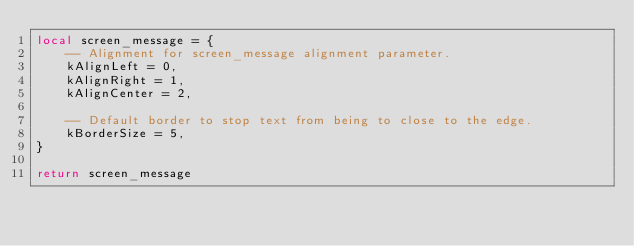Convert code to text. <code><loc_0><loc_0><loc_500><loc_500><_Lua_>local screen_message = {
    -- Alignment for screen_message alignment parameter.
    kAlignLeft = 0,
    kAlignRight = 1,
    kAlignCenter = 2,

    -- Default border to stop text from being to close to the edge.
    kBorderSize = 5,
}

return screen_message
</code> 